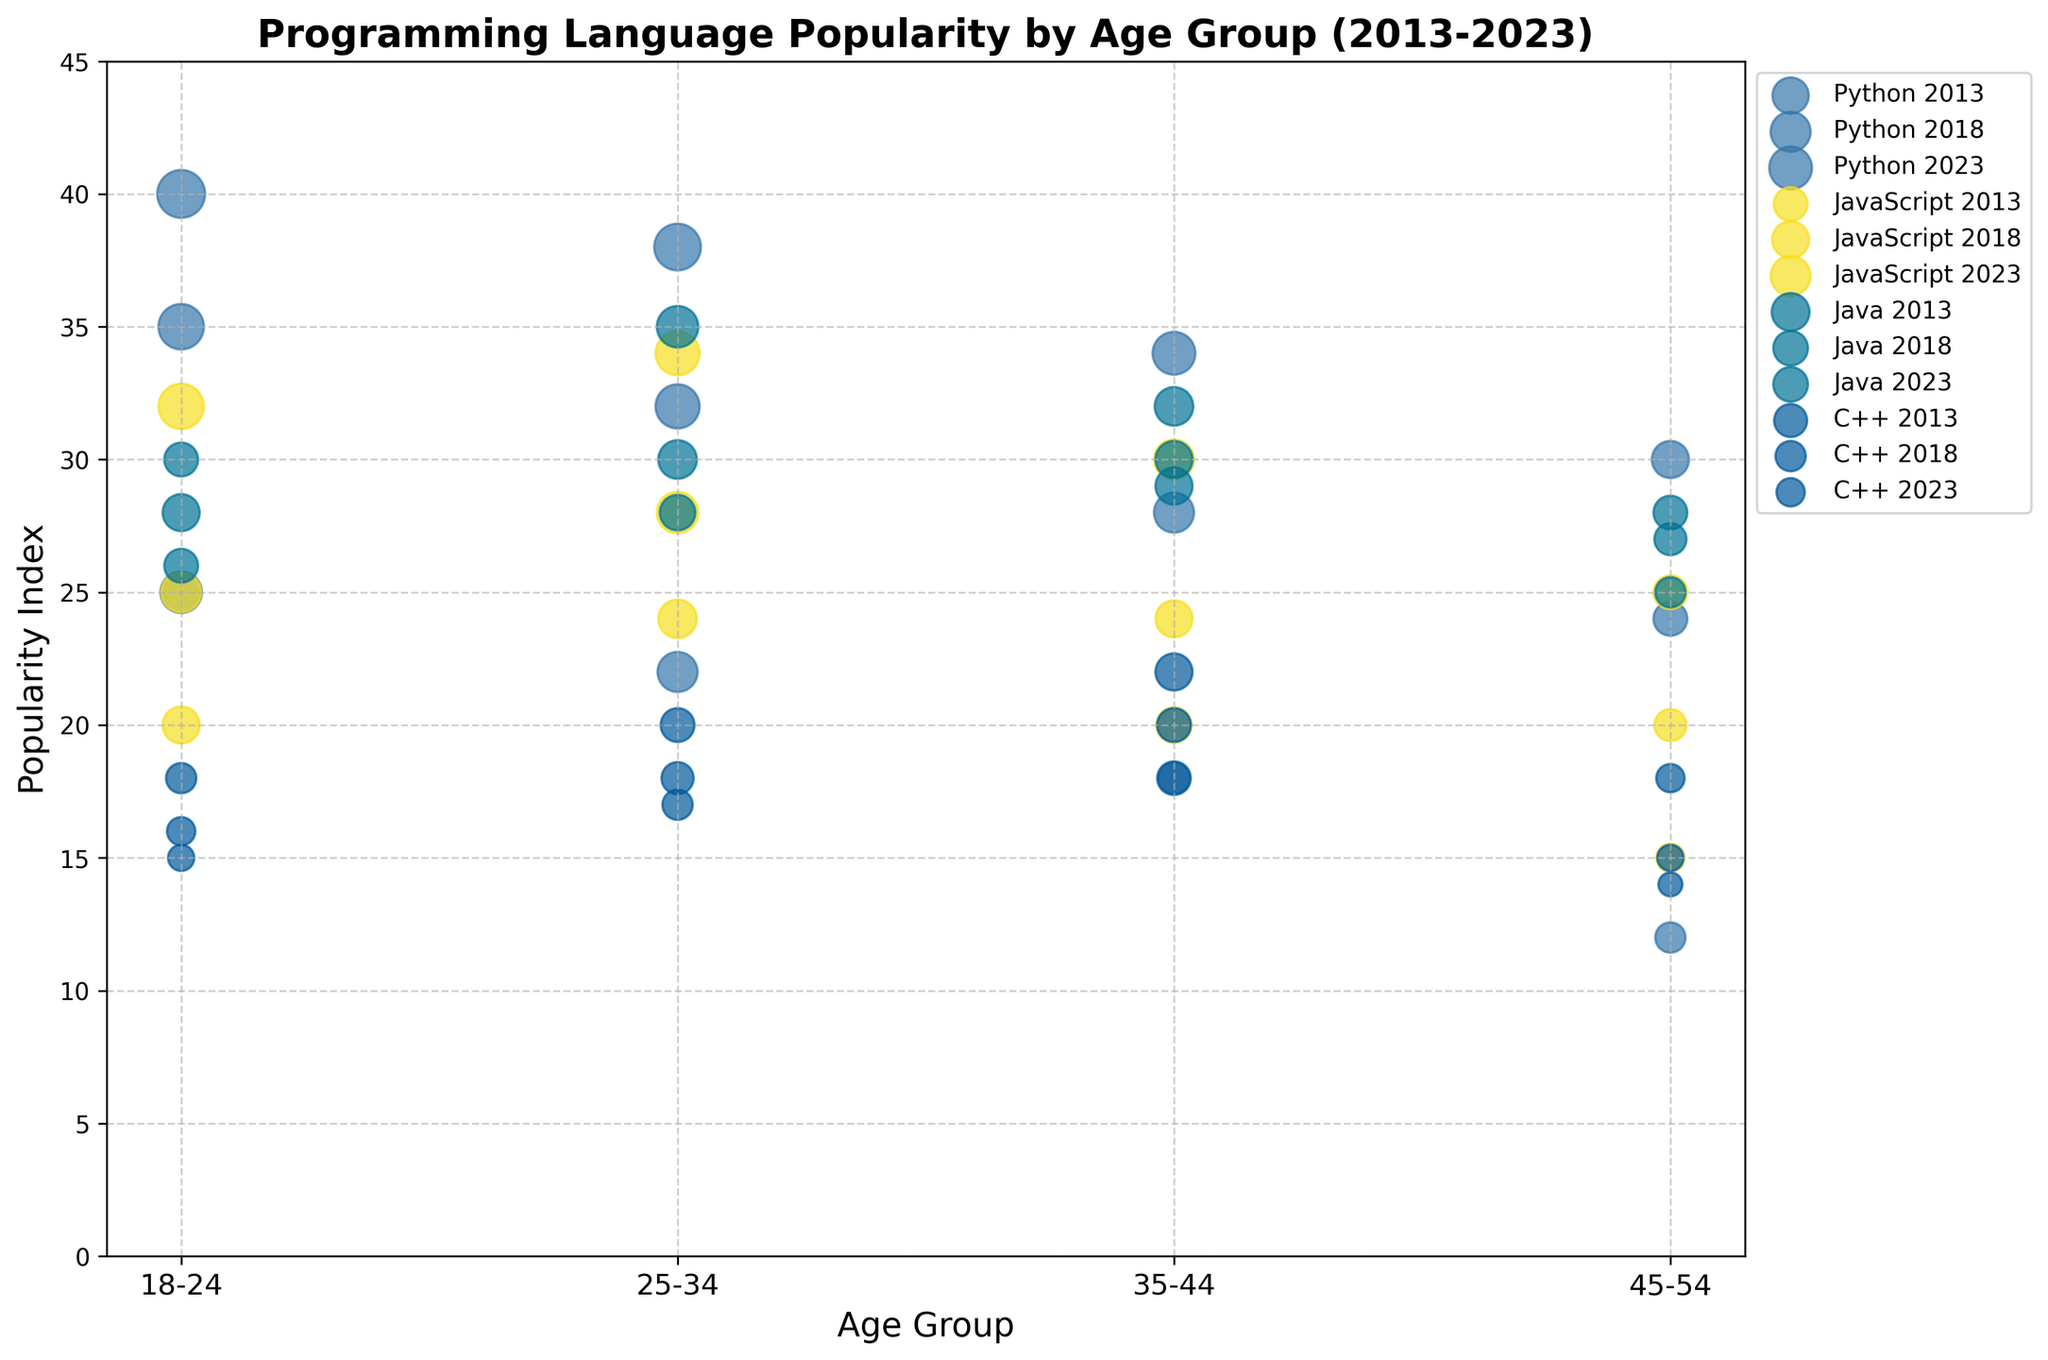What is the title of the figure? The title can be found at the top of the figure. It is "Programming Language Popularity by Age Group (2013-2023)".
Answer: Programming Language Popularity by Age Group (2013-2023) What are the X-axis and Y-axis representing? The X-axis represents "Age Group" and the Y-axis represents "Popularity Index". These labels are located along the axes.
Answer: Age Group and Popularity Index Which programming language had the highest popularity index in the 18-24 age group in 2023? By identifying the color for 2023 and the 18-24 age group, we see that Python had the highest popularity index with its bubble located the highest on the Y-axis.
Answer: Python For Python, how did the popularity index change from 2013 to 2023 in the 18-24 age group? Locate Python's bubbles for 2013 and 2023 for the 18-24 age group and compare their positions on the Y-axis. The index increased from 25 in 2013 to 40 in 2023.
Answer: Increased from 25 to 40 Which age group shows the largest bubble size for JavaScript in 2023? Inspecting JavaScript's bubbles for 2023 across different age groups, the 25-34 age group has the largest bubble, indicating the highest projected growth.
Answer: 25-34 In 2018, which programming language had the smallest popularity index in the 45-54 age group? Evaluate the Y-axis positions of the bubbles for 2018 in the 45-54 age group. C++ had the smallest popularity index.
Answer: C++ How does the popularity index for Java in the 25-34 age group change from 2013 to 2023? Track Java's bubbles for the 25-34 age group from 2013 to 2023. The popularity index decreases from 35 in 2013 to 28 in 2023.
Answer: Decreases from 35 to 28 Which programming language has the most consistent popularity index across all age groups in 2023? For 2023, observe the bubbles' Y-axis positions for consistencies among the age groups. JavaScript shows the least variance in its popularity index.
Answer: JavaScript Which two years show the most significant increase in popularity index for Python in the 35-44 age group? Compare Python's popularity index in 2013, 2018, and 2023 for the 35-44 age group. The most significant increase is from 2013 to 2018 and further from 2018 to 2023.
Answer: 2013 to 2018 and 2018 to 2023 